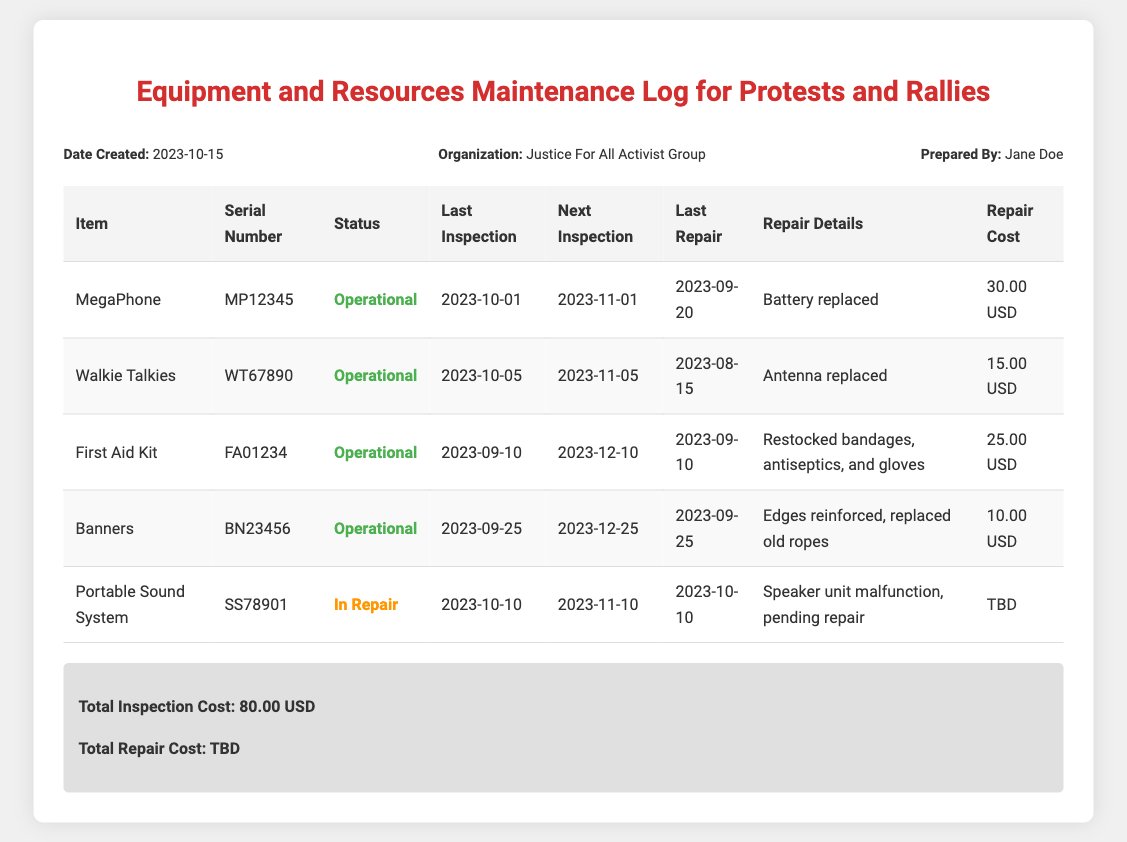What is the date the log was created? The log was created on 2023-10-15, as indicated in the header info section of the document.
Answer: 2023-10-15 Who prepared the maintenance log? The maintenance log was prepared by Jane Doe, as mentioned in the header info section.
Answer: Jane Doe What is the status of the Portable Sound System? The status of the Portable Sound System is "In Repair" as shown in the status column of the table.
Answer: In Repair What item had the last repair on 2023-09-20? The MegaPhone had its last repair on 2023-09-20, which is listed in the last repair column of the table.
Answer: MegaPhone How much was spent on repairing the First Aid Kit? The repair cost for the First Aid Kit was 25.00 USD, as specified in the repair cost column.
Answer: 25.00 USD What is the next inspection date for Walkie Talkies? The next inspection date for Walkie Talkies is 2023-11-05, mentioned in the next inspection column.
Answer: 2023-11-05 What repair details are provided for the Portable Sound System? The repair details state that the speaker unit is malfunctioning and pending repair for the Portable Sound System.
Answer: Speaker unit malfunction, pending repair What was the total inspection cost listed in the summary? The total inspection cost is 80.00 USD, which is stated in the summary section of the document.
Answer: 80.00 USD 